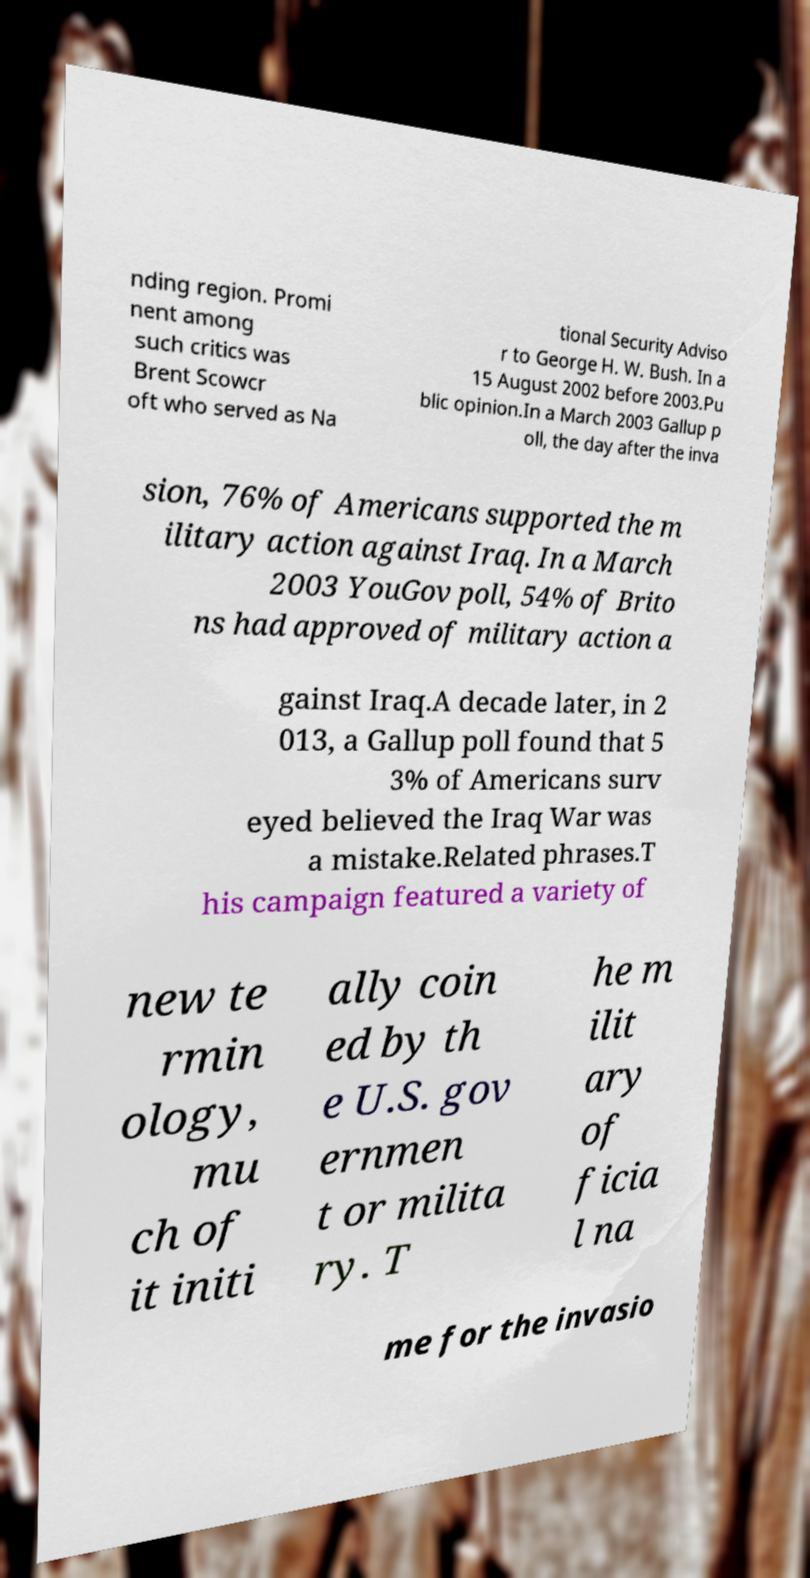Please read and relay the text visible in this image. What does it say? nding region. Promi nent among such critics was Brent Scowcr oft who served as Na tional Security Adviso r to George H. W. Bush. In a 15 August 2002 before 2003.Pu blic opinion.In a March 2003 Gallup p oll, the day after the inva sion, 76% of Americans supported the m ilitary action against Iraq. In a March 2003 YouGov poll, 54% of Brito ns had approved of military action a gainst Iraq.A decade later, in 2 013, a Gallup poll found that 5 3% of Americans surv eyed believed the Iraq War was a mistake.Related phrases.T his campaign featured a variety of new te rmin ology, mu ch of it initi ally coin ed by th e U.S. gov ernmen t or milita ry. T he m ilit ary of ficia l na me for the invasio 